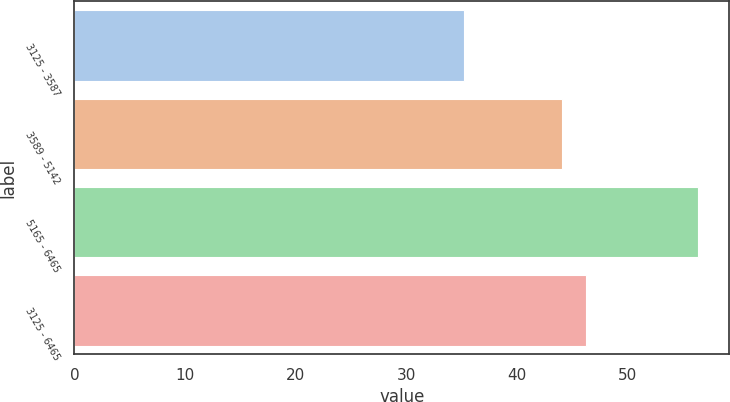Convert chart. <chart><loc_0><loc_0><loc_500><loc_500><bar_chart><fcel>3125 - 3587<fcel>3589 - 5142<fcel>5165 - 6465<fcel>3125 - 6465<nl><fcel>35.17<fcel>44.11<fcel>56.39<fcel>46.23<nl></chart> 